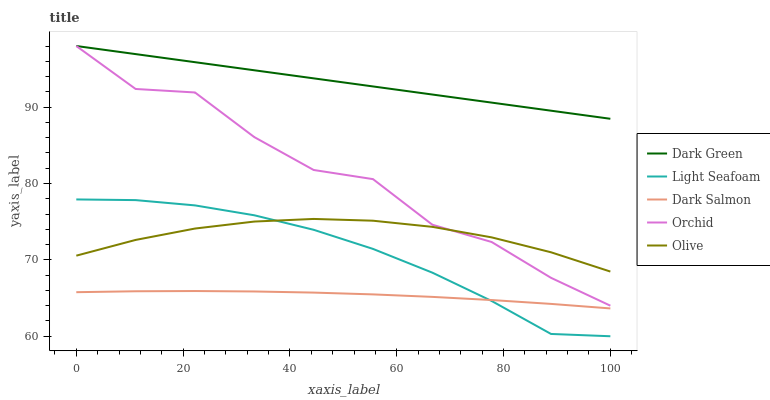Does Dark Salmon have the minimum area under the curve?
Answer yes or no. Yes. Does Dark Green have the maximum area under the curve?
Answer yes or no. Yes. Does Olive have the minimum area under the curve?
Answer yes or no. No. Does Olive have the maximum area under the curve?
Answer yes or no. No. Is Dark Green the smoothest?
Answer yes or no. Yes. Is Orchid the roughest?
Answer yes or no. Yes. Is Olive the smoothest?
Answer yes or no. No. Is Olive the roughest?
Answer yes or no. No. Does Light Seafoam have the lowest value?
Answer yes or no. Yes. Does Olive have the lowest value?
Answer yes or no. No. Does Dark Green have the highest value?
Answer yes or no. Yes. Does Olive have the highest value?
Answer yes or no. No. Is Dark Salmon less than Olive?
Answer yes or no. Yes. Is Orchid greater than Dark Salmon?
Answer yes or no. Yes. Does Light Seafoam intersect Olive?
Answer yes or no. Yes. Is Light Seafoam less than Olive?
Answer yes or no. No. Is Light Seafoam greater than Olive?
Answer yes or no. No. Does Dark Salmon intersect Olive?
Answer yes or no. No. 